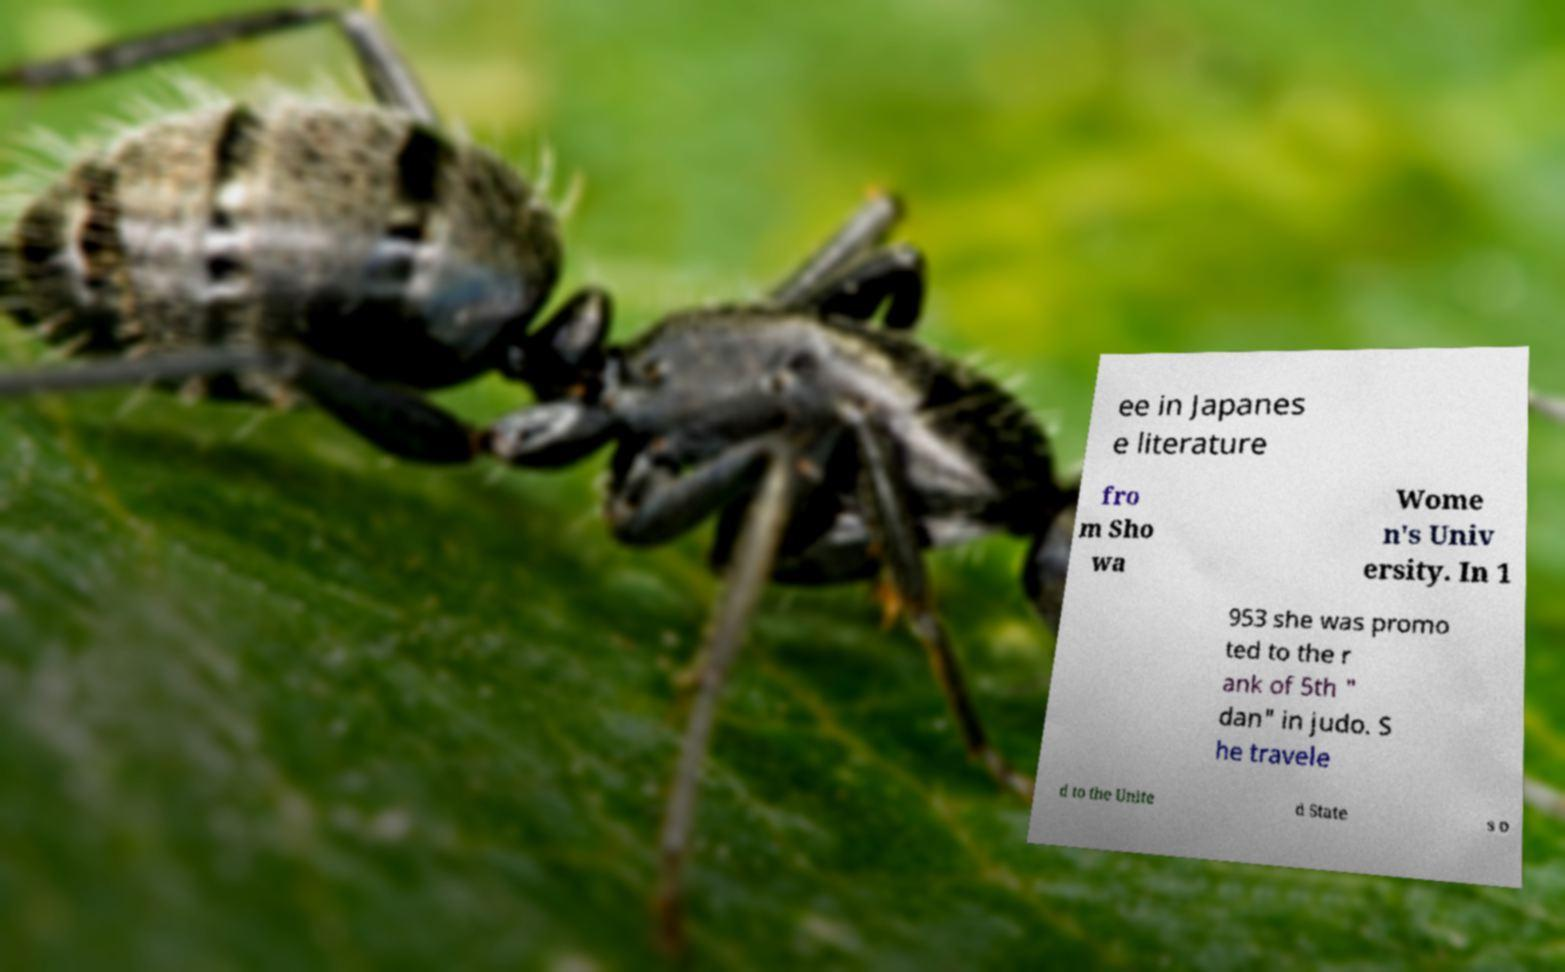Could you assist in decoding the text presented in this image and type it out clearly? ee in Japanes e literature fro m Sho wa Wome n's Univ ersity. In 1 953 she was promo ted to the r ank of 5th " dan" in judo. S he travele d to the Unite d State s o 